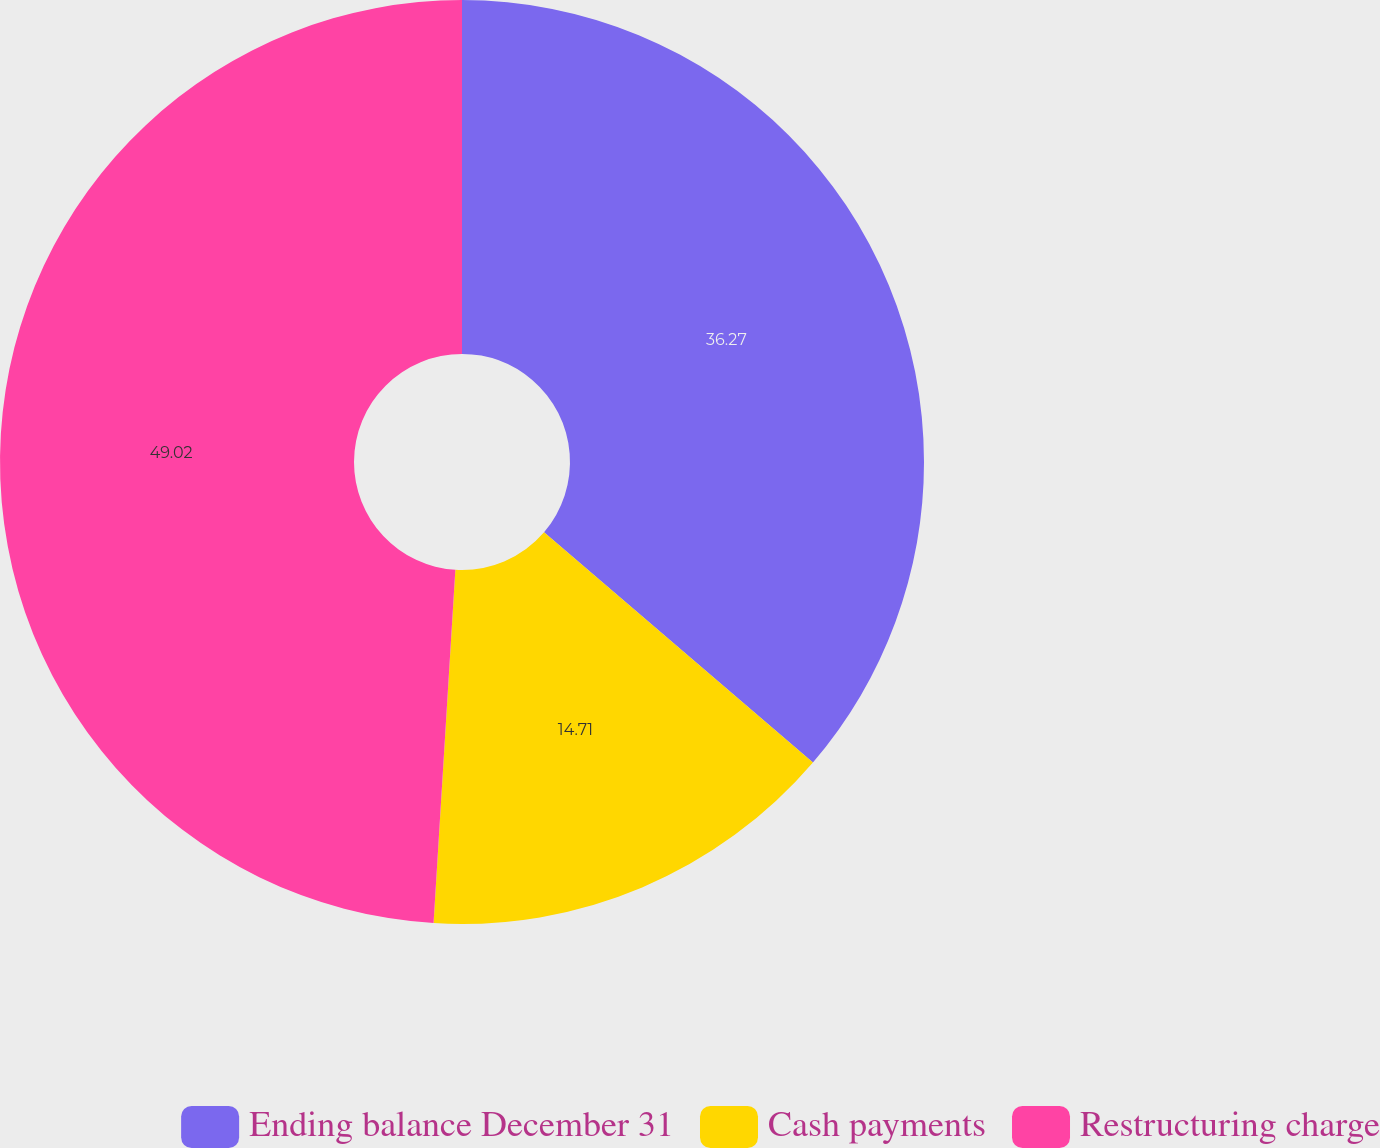Convert chart to OTSL. <chart><loc_0><loc_0><loc_500><loc_500><pie_chart><fcel>Ending balance December 31<fcel>Cash payments<fcel>Restructuring charge<nl><fcel>36.27%<fcel>14.71%<fcel>49.02%<nl></chart> 